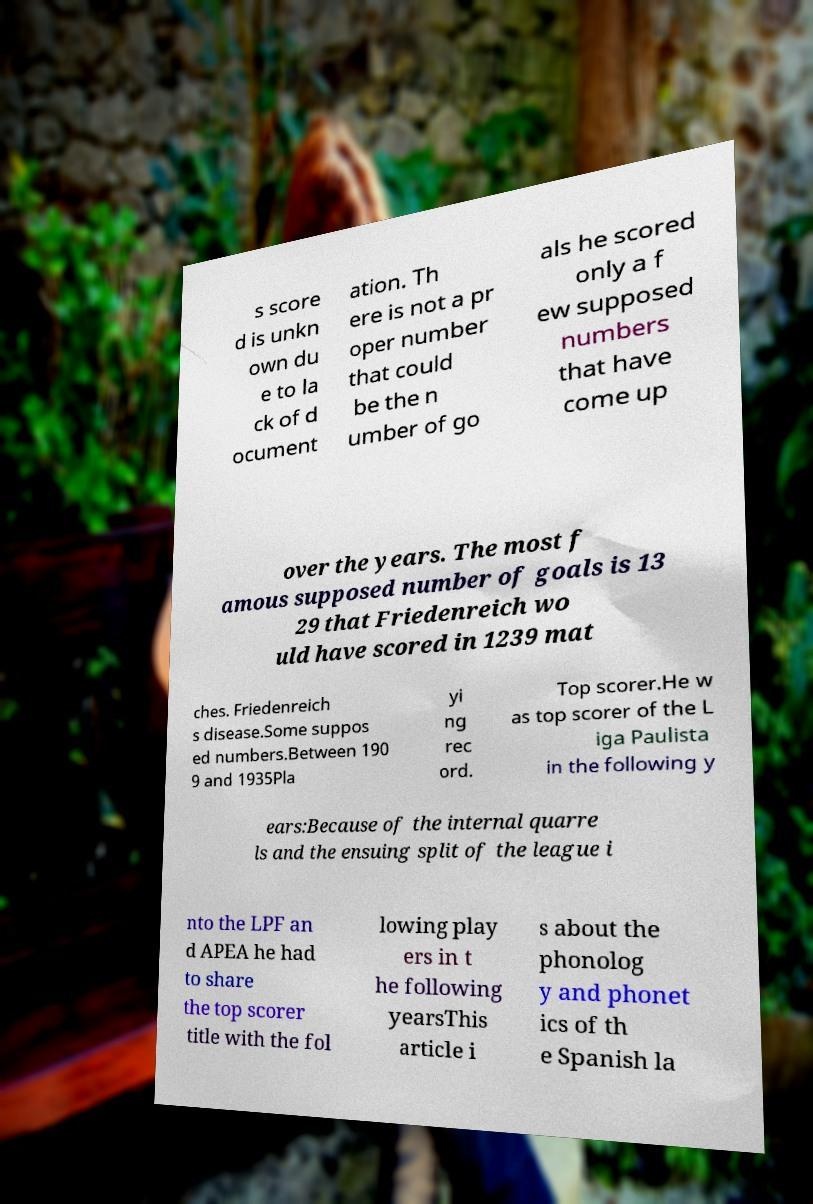Please identify and transcribe the text found in this image. s score d is unkn own du e to la ck of d ocument ation. Th ere is not a pr oper number that could be the n umber of go als he scored only a f ew supposed numbers that have come up over the years. The most f amous supposed number of goals is 13 29 that Friedenreich wo uld have scored in 1239 mat ches. Friedenreich s disease.Some suppos ed numbers.Between 190 9 and 1935Pla yi ng rec ord. Top scorer.He w as top scorer of the L iga Paulista in the following y ears:Because of the internal quarre ls and the ensuing split of the league i nto the LPF an d APEA he had to share the top scorer title with the fol lowing play ers in t he following yearsThis article i s about the phonolog y and phonet ics of th e Spanish la 